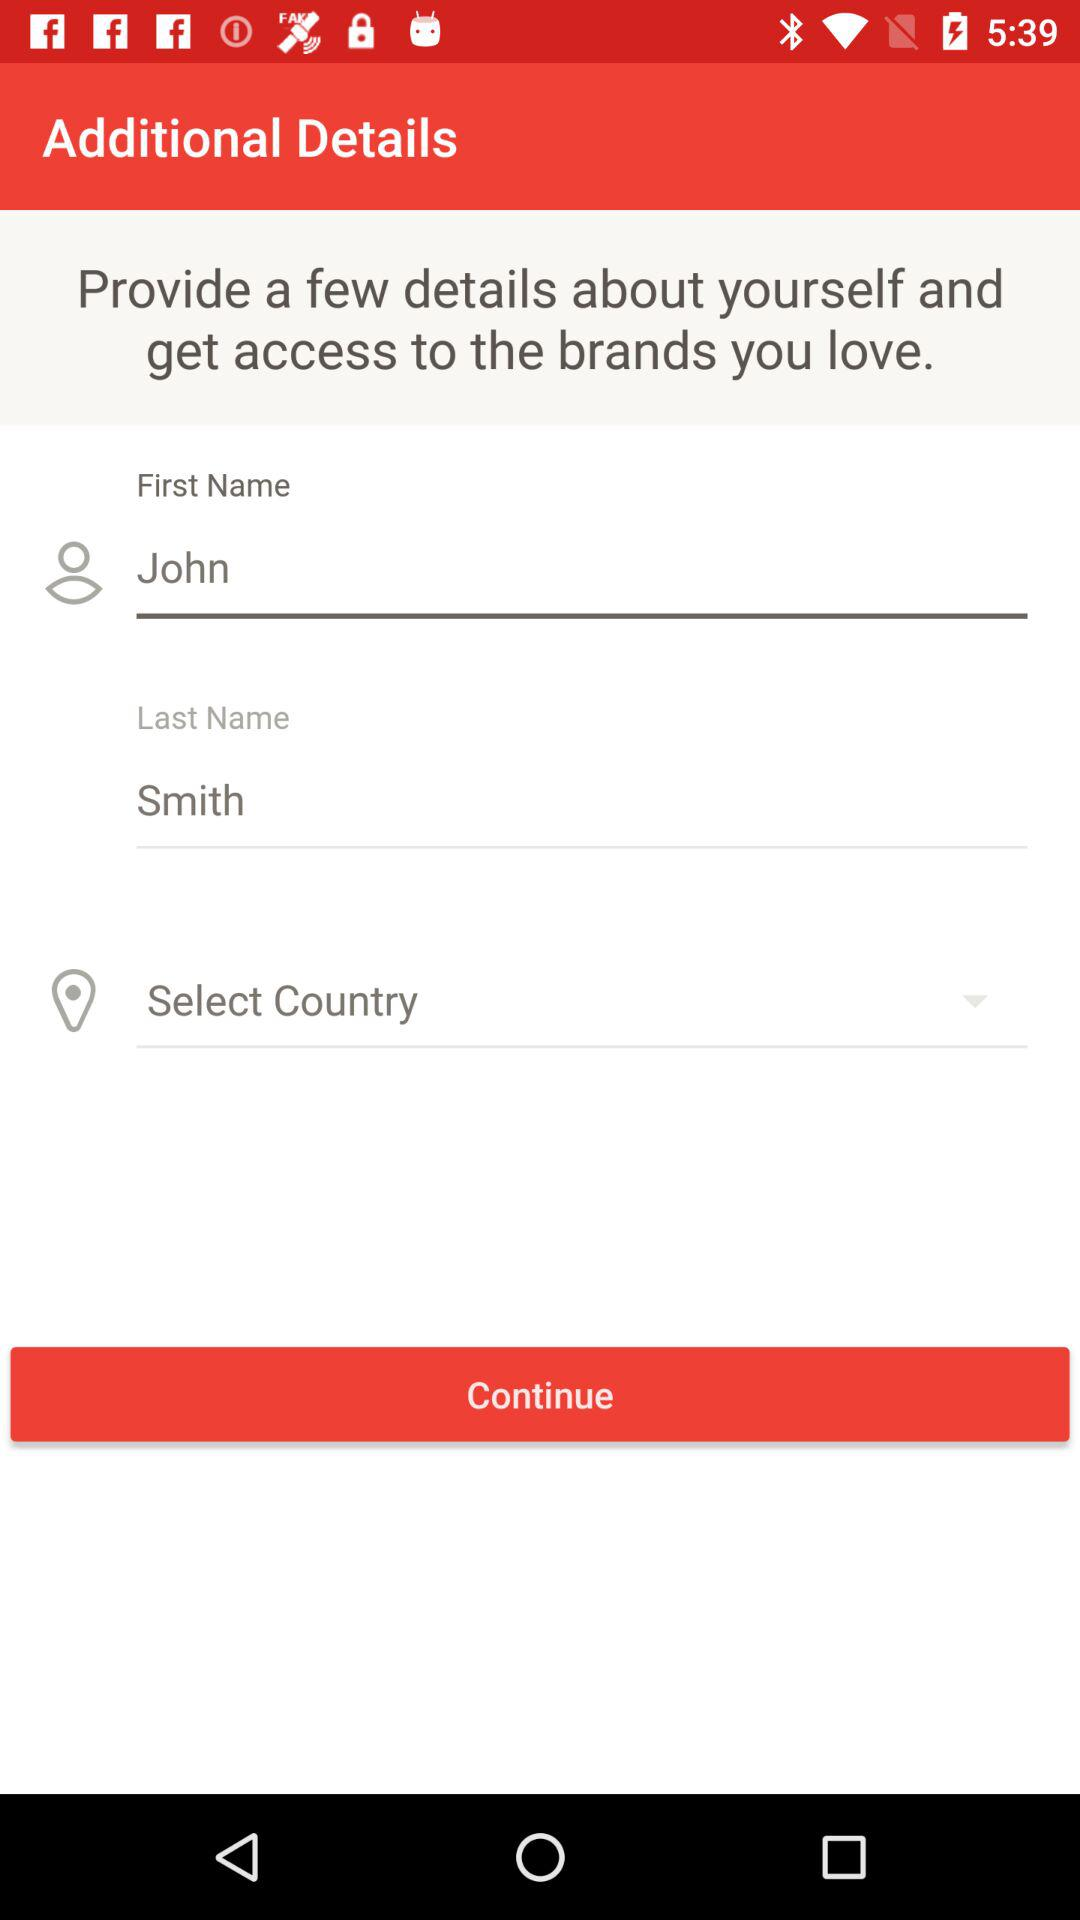What's the user last name? The last name is Smith. 